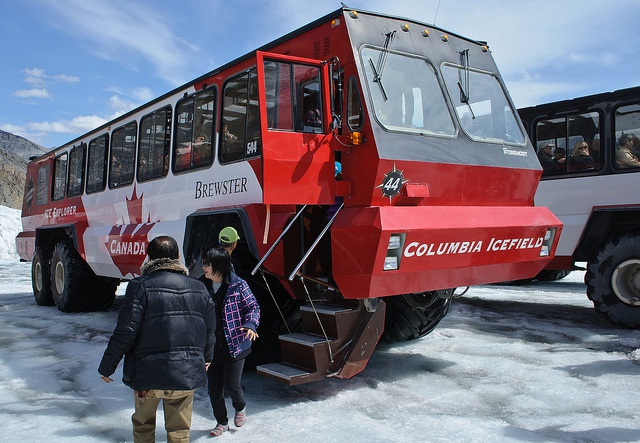Describe the objects in this image and their specific colors. I can see bus in gray, black, darkgray, maroon, and brown tones, bus in gray and black tones, people in gray and black tones, people in gray, black, and navy tones, and people in gray and black tones in this image. 